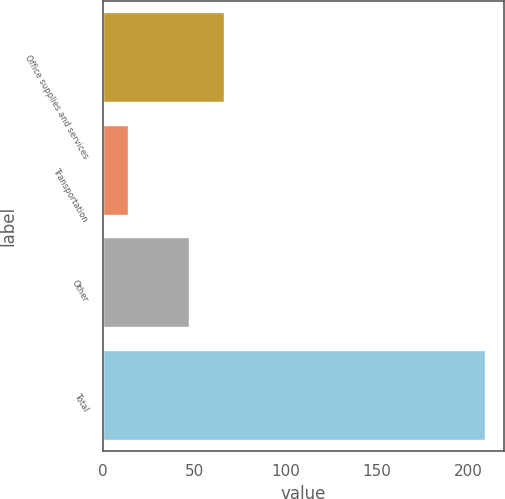<chart> <loc_0><loc_0><loc_500><loc_500><bar_chart><fcel>Office supplies and services<fcel>Transportation<fcel>Other<fcel>Total<nl><fcel>66.5<fcel>14<fcel>47<fcel>209<nl></chart> 